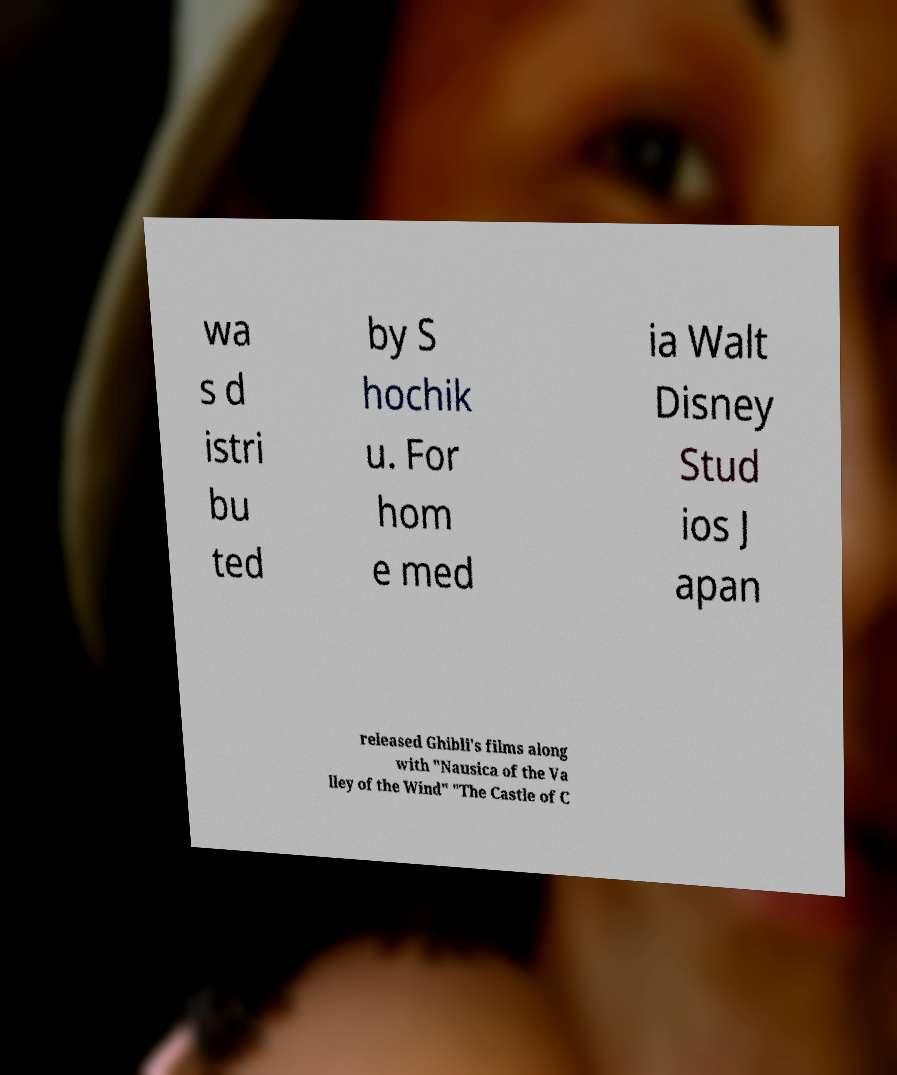What messages or text are displayed in this image? I need them in a readable, typed format. wa s d istri bu ted by S hochik u. For hom e med ia Walt Disney Stud ios J apan released Ghibli's films along with "Nausica of the Va lley of the Wind" "The Castle of C 